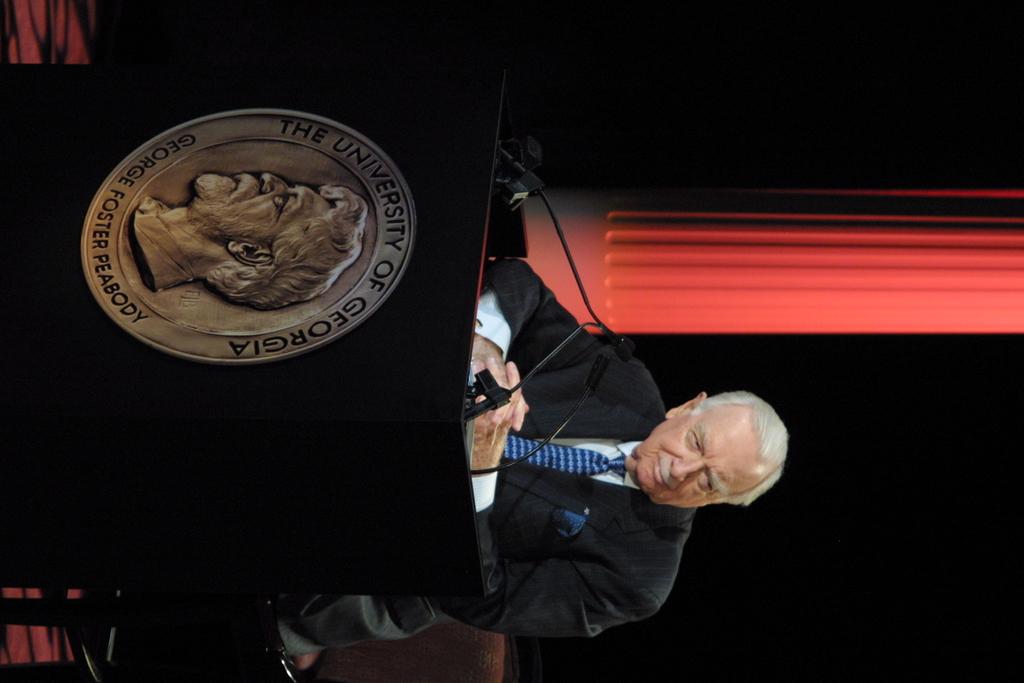Where is this podium from?
Provide a short and direct response. The university of georgia. What name is on the bottom of the round seal?
Your answer should be compact. George foster peabody. 